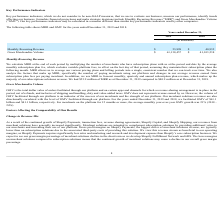From Shopify's financial document, What are the 2 financial items listed in the table? The document shows two values: Monthly Recurring Revenue and Gross Merchandise Volume. From the document: "ons include Monthly Recurring Revenue ("MRR") and Gross Merchandise Volume ("GMV"). Our key performance indicators may be calculated in a manner diffe..." Also, Which financial years' information is shown in the table? The document shows two values: 2018 and 2019. From the document: "2019 2018 2019 2018..." Also, What is the full form of "MRR"? Monthly Recurring Revenue. The document states: "projections and make strategic decisions include Monthly Recurring Revenue ("MRR") and Gross Merchandise Volume ("GMV"). Our key performance indicator..." Also, can you calculate: What is the average monthly recurring revenue for 2018 and 2019? To answer this question, I need to perform calculations using the financial data. The calculation is: (53,898+40,932)/2, which equals 47415 (in thousands). This is based on the information: "Monthly Recurring Revenue $ 53,898 $ 40,932 Monthly Recurring Revenue $ 53,898 $ 40,932..." The key data points involved are: 40,932, 53,898. Also, can you calculate: What is the average gross merchandise volume for 2018 and 2019? To answer this question, I need to perform calculations using the financial data. The calculation is: (61,138,457+41,103,238)/2, which equals 51120847.5 (in thousands). This is based on the information: "Gross Merchandise Volume $ 61,138,457 $ 41,103,238 Gross Merchandise Volume $ 61,138,457 $ 41,103,238..." The key data points involved are: 41,103,238, 61,138,457. Also, can you calculate: What is the change between 2018 and 2019 year ended's monthly recurring revenue ? Based on the calculation: 53,898-40,932, the result is 12966 (in thousands). This is based on the information: "Monthly Recurring Revenue $ 53,898 $ 40,932 Monthly Recurring Revenue $ 53,898 $ 40,932..." The key data points involved are: 40,932, 53,898. 